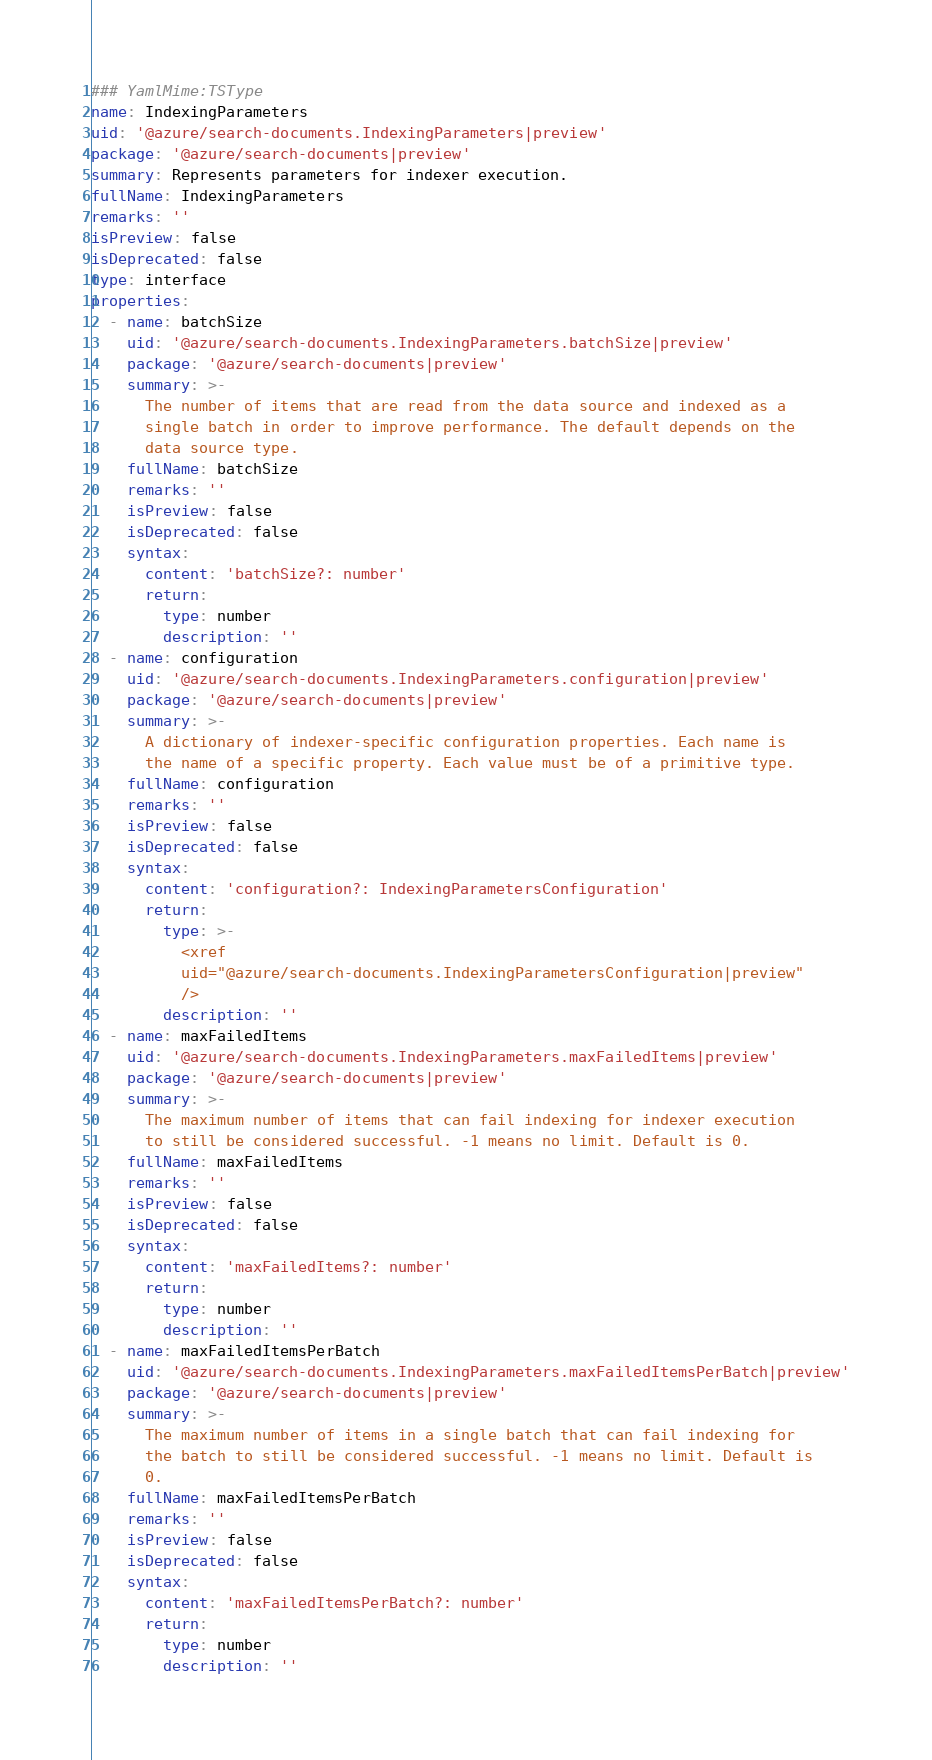<code> <loc_0><loc_0><loc_500><loc_500><_YAML_>### YamlMime:TSType
name: IndexingParameters
uid: '@azure/search-documents.IndexingParameters|preview'
package: '@azure/search-documents|preview'
summary: Represents parameters for indexer execution.
fullName: IndexingParameters
remarks: ''
isPreview: false
isDeprecated: false
type: interface
properties:
  - name: batchSize
    uid: '@azure/search-documents.IndexingParameters.batchSize|preview'
    package: '@azure/search-documents|preview'
    summary: >-
      The number of items that are read from the data source and indexed as a
      single batch in order to improve performance. The default depends on the
      data source type.
    fullName: batchSize
    remarks: ''
    isPreview: false
    isDeprecated: false
    syntax:
      content: 'batchSize?: number'
      return:
        type: number
        description: ''
  - name: configuration
    uid: '@azure/search-documents.IndexingParameters.configuration|preview'
    package: '@azure/search-documents|preview'
    summary: >-
      A dictionary of indexer-specific configuration properties. Each name is
      the name of a specific property. Each value must be of a primitive type.
    fullName: configuration
    remarks: ''
    isPreview: false
    isDeprecated: false
    syntax:
      content: 'configuration?: IndexingParametersConfiguration'
      return:
        type: >-
          <xref
          uid="@azure/search-documents.IndexingParametersConfiguration|preview"
          />
        description: ''
  - name: maxFailedItems
    uid: '@azure/search-documents.IndexingParameters.maxFailedItems|preview'
    package: '@azure/search-documents|preview'
    summary: >-
      The maximum number of items that can fail indexing for indexer execution
      to still be considered successful. -1 means no limit. Default is 0.
    fullName: maxFailedItems
    remarks: ''
    isPreview: false
    isDeprecated: false
    syntax:
      content: 'maxFailedItems?: number'
      return:
        type: number
        description: ''
  - name: maxFailedItemsPerBatch
    uid: '@azure/search-documents.IndexingParameters.maxFailedItemsPerBatch|preview'
    package: '@azure/search-documents|preview'
    summary: >-
      The maximum number of items in a single batch that can fail indexing for
      the batch to still be considered successful. -1 means no limit. Default is
      0.
    fullName: maxFailedItemsPerBatch
    remarks: ''
    isPreview: false
    isDeprecated: false
    syntax:
      content: 'maxFailedItemsPerBatch?: number'
      return:
        type: number
        description: ''
</code> 